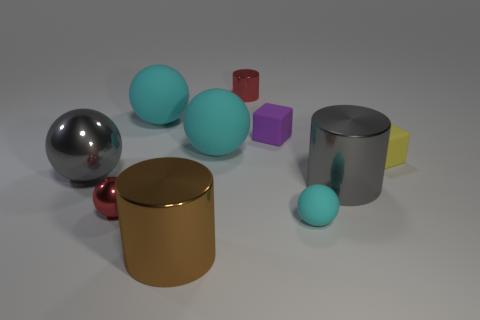Are there the same number of metallic cylinders in front of the big metal ball and large things that are on the right side of the big brown cylinder?
Provide a succinct answer. Yes. How many other objects are there of the same material as the tiny yellow block?
Your response must be concise. 4. How many big things are brown objects or gray shiny spheres?
Make the answer very short. 2. Is the number of small cyan objects that are behind the small yellow object the same as the number of cyan rubber balls?
Your answer should be very brief. No. Is there a big gray cylinder to the left of the large gray shiny ball that is to the left of the tiny yellow cube?
Offer a very short reply. No. What number of other objects are there of the same color as the big shiny ball?
Offer a very short reply. 1. The tiny matte ball is what color?
Offer a terse response. Cyan. There is a cylinder that is behind the red sphere and to the left of the small cyan object; how big is it?
Give a very brief answer. Small. How many objects are either big cyan rubber things right of the brown metal cylinder or tiny metal objects?
Your response must be concise. 3. What shape is the small purple thing that is made of the same material as the yellow block?
Provide a short and direct response. Cube. 